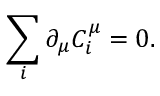Convert formula to latex. <formula><loc_0><loc_0><loc_500><loc_500>\sum _ { i } \partial _ { \mu } C _ { i } ^ { \mu } = 0 .</formula> 